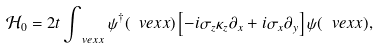<formula> <loc_0><loc_0><loc_500><loc_500>\mathcal { H } _ { 0 } = 2 t \int _ { \ v e x { x } } \psi ^ { \dagger } ( \ v e x { x } ) \left [ - i \sigma _ { z } \kappa _ { z } \partial _ { x } + i \sigma _ { x } \partial _ { y } \right ] \psi ( \ v e x { x } ) ,</formula> 